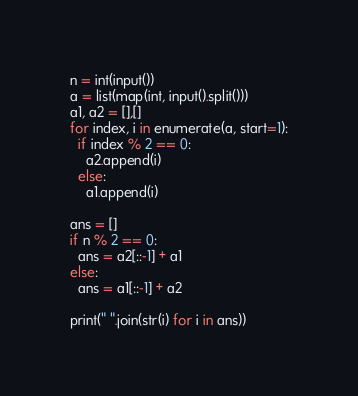<code> <loc_0><loc_0><loc_500><loc_500><_Python_>n = int(input())
a = list(map(int, input().split()))
a1, a2 = [],[]
for index, i in enumerate(a, start=1):
  if index % 2 == 0:
    a2.append(i)
  else:
    a1.append(i)

ans = []
if n % 2 == 0:
  ans = a2[::-1] + a1
else:
  ans = a1[::-1] + a2

print(" ".join(str(i) for i in ans))</code> 